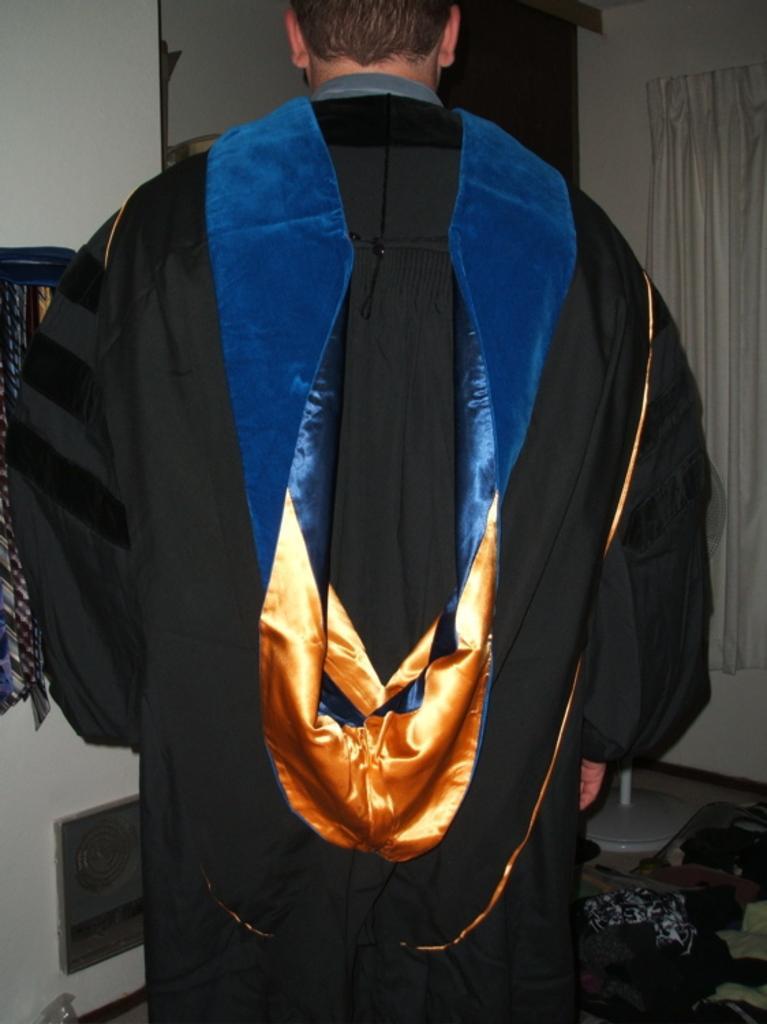In one or two sentences, can you explain what this image depicts? In the center of the image a man is standing and wearing graduation dress. In the background of the image we can see wall, curtain, door are there. At the bottom right corner some clothes, floor are there. At the bottom left corner cupboard is there. 